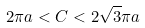Convert formula to latex. <formula><loc_0><loc_0><loc_500><loc_500>2 \pi a < C < 2 \sqrt { 3 } \pi a</formula> 